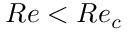<formula> <loc_0><loc_0><loc_500><loc_500>R e < R e _ { c }</formula> 